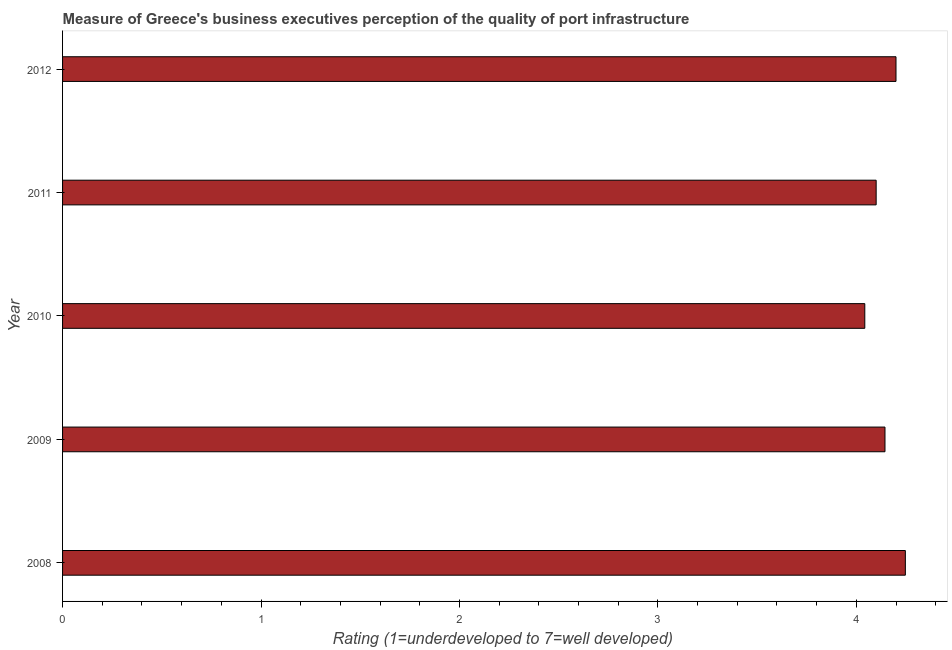What is the title of the graph?
Ensure brevity in your answer.  Measure of Greece's business executives perception of the quality of port infrastructure. What is the label or title of the X-axis?
Ensure brevity in your answer.  Rating (1=underdeveloped to 7=well developed) . What is the label or title of the Y-axis?
Offer a terse response. Year. What is the rating measuring quality of port infrastructure in 2010?
Your answer should be compact. 4.04. Across all years, what is the maximum rating measuring quality of port infrastructure?
Your response must be concise. 4.25. Across all years, what is the minimum rating measuring quality of port infrastructure?
Provide a short and direct response. 4.04. In which year was the rating measuring quality of port infrastructure maximum?
Keep it short and to the point. 2008. What is the sum of the rating measuring quality of port infrastructure?
Keep it short and to the point. 20.73. What is the difference between the rating measuring quality of port infrastructure in 2008 and 2011?
Provide a short and direct response. 0.15. What is the average rating measuring quality of port infrastructure per year?
Keep it short and to the point. 4.15. What is the median rating measuring quality of port infrastructure?
Provide a short and direct response. 4.14. Do a majority of the years between 2011 and 2010 (inclusive) have rating measuring quality of port infrastructure greater than 4 ?
Keep it short and to the point. No. Is the rating measuring quality of port infrastructure in 2008 less than that in 2010?
Keep it short and to the point. No. What is the difference between the highest and the second highest rating measuring quality of port infrastructure?
Your answer should be compact. 0.05. How many bars are there?
Keep it short and to the point. 5. What is the difference between two consecutive major ticks on the X-axis?
Ensure brevity in your answer.  1. What is the Rating (1=underdeveloped to 7=well developed)  of 2008?
Give a very brief answer. 4.25. What is the Rating (1=underdeveloped to 7=well developed)  of 2009?
Offer a terse response. 4.14. What is the Rating (1=underdeveloped to 7=well developed)  of 2010?
Provide a succinct answer. 4.04. What is the Rating (1=underdeveloped to 7=well developed)  of 2011?
Keep it short and to the point. 4.1. What is the Rating (1=underdeveloped to 7=well developed)  in 2012?
Your answer should be compact. 4.2. What is the difference between the Rating (1=underdeveloped to 7=well developed)  in 2008 and 2009?
Ensure brevity in your answer.  0.1. What is the difference between the Rating (1=underdeveloped to 7=well developed)  in 2008 and 2010?
Give a very brief answer. 0.2. What is the difference between the Rating (1=underdeveloped to 7=well developed)  in 2008 and 2011?
Make the answer very short. 0.15. What is the difference between the Rating (1=underdeveloped to 7=well developed)  in 2008 and 2012?
Provide a succinct answer. 0.05. What is the difference between the Rating (1=underdeveloped to 7=well developed)  in 2009 and 2010?
Your answer should be very brief. 0.1. What is the difference between the Rating (1=underdeveloped to 7=well developed)  in 2009 and 2011?
Your answer should be very brief. 0.04. What is the difference between the Rating (1=underdeveloped to 7=well developed)  in 2009 and 2012?
Make the answer very short. -0.06. What is the difference between the Rating (1=underdeveloped to 7=well developed)  in 2010 and 2011?
Your answer should be very brief. -0.06. What is the difference between the Rating (1=underdeveloped to 7=well developed)  in 2010 and 2012?
Ensure brevity in your answer.  -0.16. What is the difference between the Rating (1=underdeveloped to 7=well developed)  in 2011 and 2012?
Give a very brief answer. -0.1. What is the ratio of the Rating (1=underdeveloped to 7=well developed)  in 2008 to that in 2010?
Your response must be concise. 1.05. What is the ratio of the Rating (1=underdeveloped to 7=well developed)  in 2008 to that in 2011?
Offer a terse response. 1.04. What is the ratio of the Rating (1=underdeveloped to 7=well developed)  in 2008 to that in 2012?
Your answer should be compact. 1.01. What is the ratio of the Rating (1=underdeveloped to 7=well developed)  in 2009 to that in 2010?
Keep it short and to the point. 1.02. What is the ratio of the Rating (1=underdeveloped to 7=well developed)  in 2009 to that in 2012?
Your answer should be compact. 0.99. What is the ratio of the Rating (1=underdeveloped to 7=well developed)  in 2010 to that in 2012?
Ensure brevity in your answer.  0.96. What is the ratio of the Rating (1=underdeveloped to 7=well developed)  in 2011 to that in 2012?
Provide a short and direct response. 0.98. 